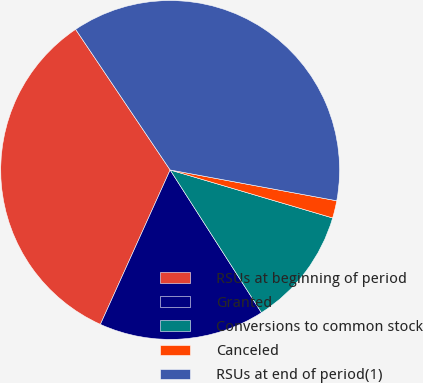<chart> <loc_0><loc_0><loc_500><loc_500><pie_chart><fcel>RSUs at beginning of period<fcel>Granted<fcel>Conversions to common stock<fcel>Canceled<fcel>RSUs at end of period(1)<nl><fcel>33.83%<fcel>15.81%<fcel>11.37%<fcel>1.66%<fcel>37.33%<nl></chart> 